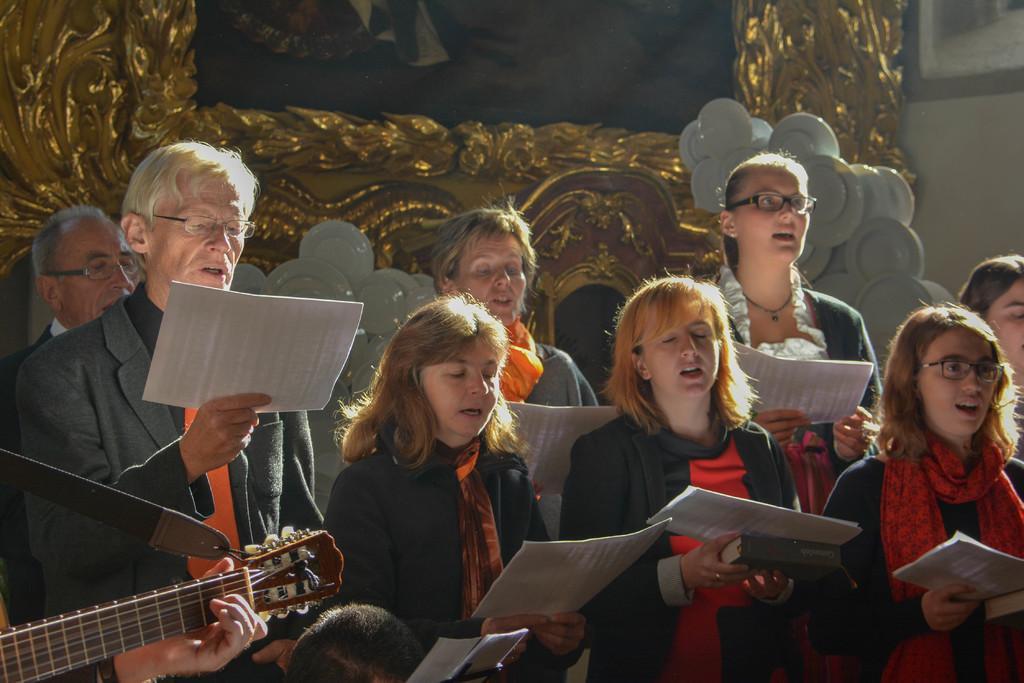In one or two sentences, can you explain what this image depicts? In this picture we can see some persons standing and holding a paper with their hands. And this is the guitar and there is a wall. 